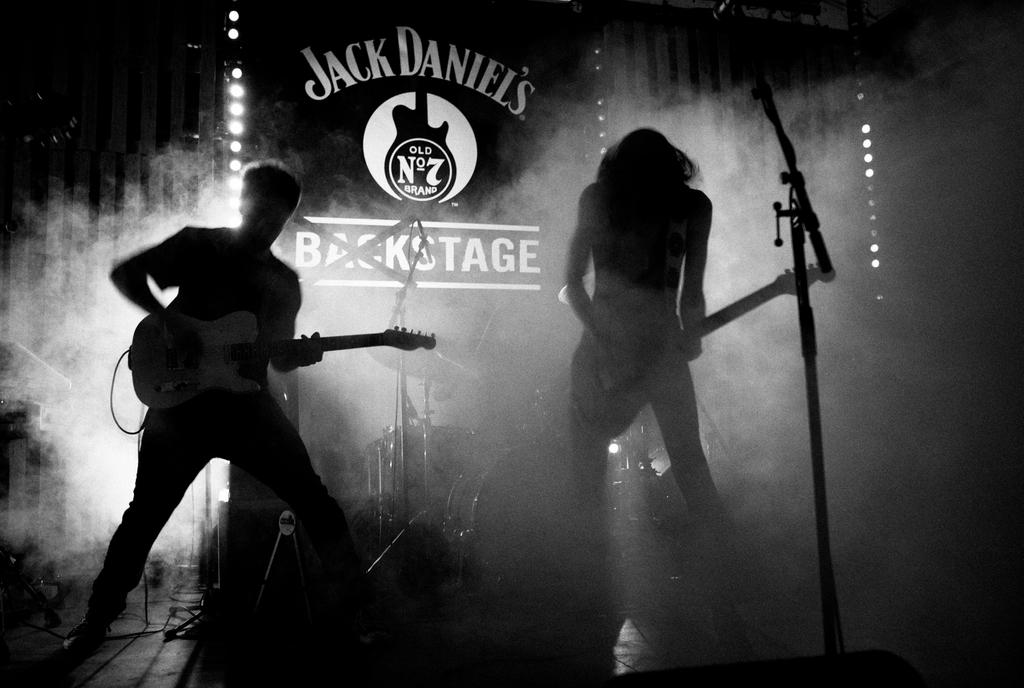How many people are in the image? There are two people in the image. What are the people doing in the image? The people are standing and playing musical instruments. What can be seen in the background of the image? There is a banner and a drum set in the background of the image. Is there any visible effect caused by the musical instruments in the image? Yes, there is smoke visible in the image. What type of bat can be seen flying in the image? There is no bat visible in the image; it features two people playing musical instruments. Is there a beast present in the image? There is no beast present in the image. 